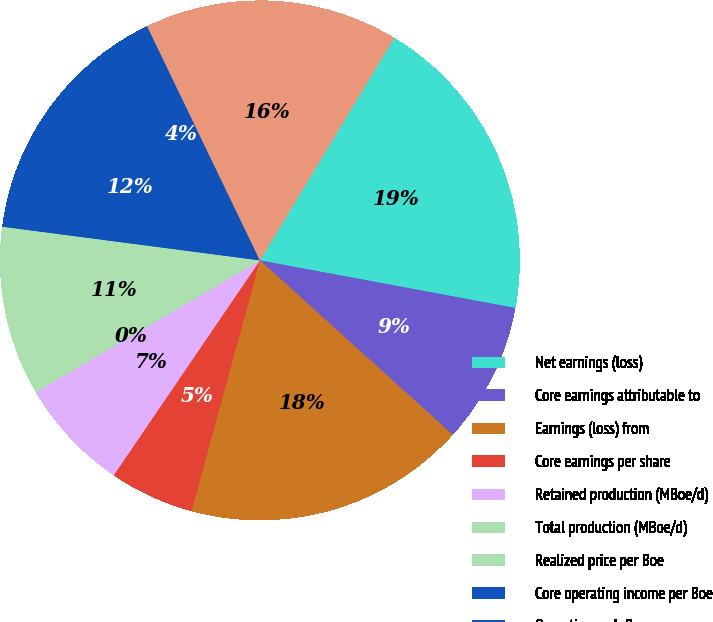<chart> <loc_0><loc_0><loc_500><loc_500><pie_chart><fcel>Net earnings (loss)<fcel>Core earnings attributable to<fcel>Earnings (loss) from<fcel>Core earnings per share<fcel>Retained production (MBoe/d)<fcel>Total production (MBoe/d)<fcel>Realized price per Boe<fcel>Core operating income per Boe<fcel>Operating cash flow -<fcel>Capitalized costs including<nl><fcel>19.29%<fcel>8.77%<fcel>17.54%<fcel>5.27%<fcel>7.02%<fcel>0.01%<fcel>10.53%<fcel>12.28%<fcel>3.51%<fcel>15.79%<nl></chart> 